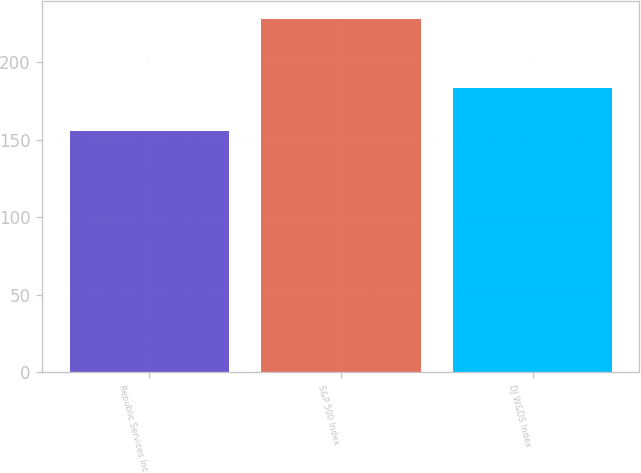Convert chart. <chart><loc_0><loc_0><loc_500><loc_500><bar_chart><fcel>Republic Services Inc<fcel>S&P 500 Index<fcel>DJ W&DS Index<nl><fcel>155.65<fcel>228.19<fcel>183.62<nl></chart> 